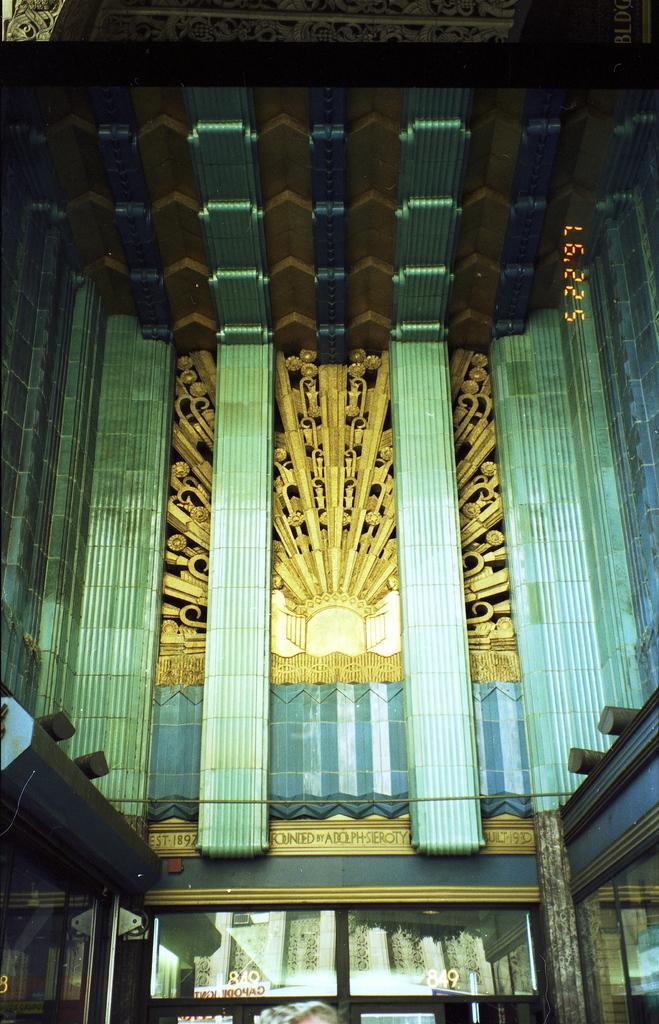In one or two sentences, can you explain what this image depicts? In this image we can see a building with pillars, cable, air conditioner and windows. 